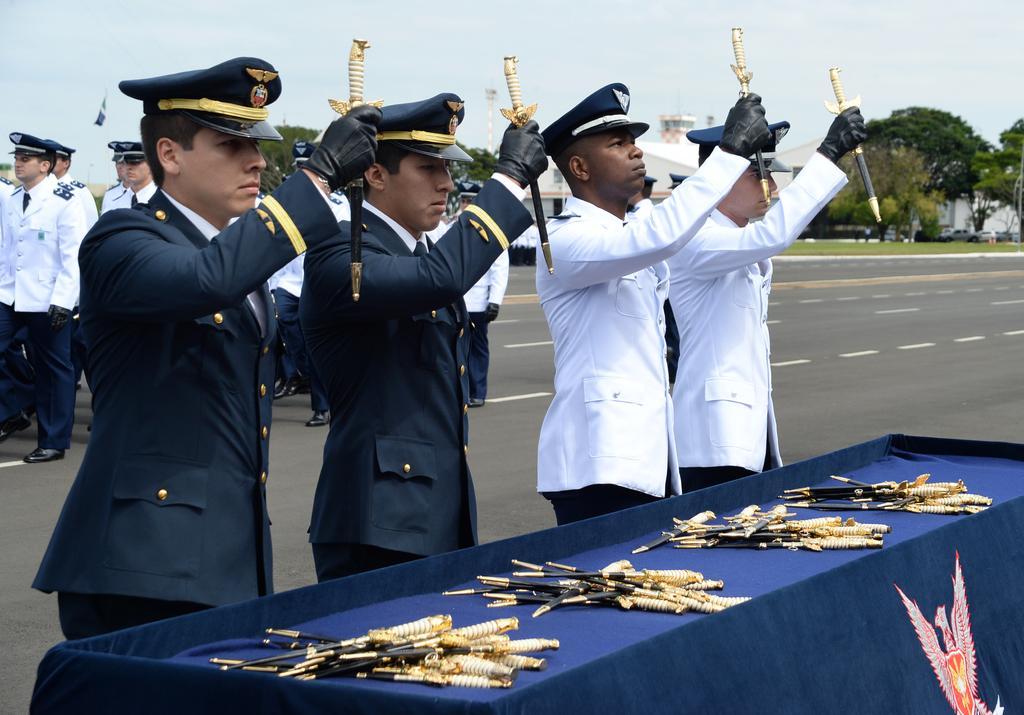Can you describe this image briefly? Here we can see four men standing and holding knives in their hands and on the table we can see four pairs of knives. In the background we can see few people are marching on the road,trees,buildings,poles,vehicles and sky. 